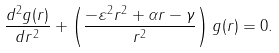Convert formula to latex. <formula><loc_0><loc_0><loc_500><loc_500>\frac { d ^ { 2 } g ( r ) } { d r ^ { 2 } } + \left ( \frac { - \varepsilon ^ { 2 } r ^ { 2 } + \alpha r - \gamma } { r ^ { 2 } } \right ) g ( r ) = 0 .</formula> 